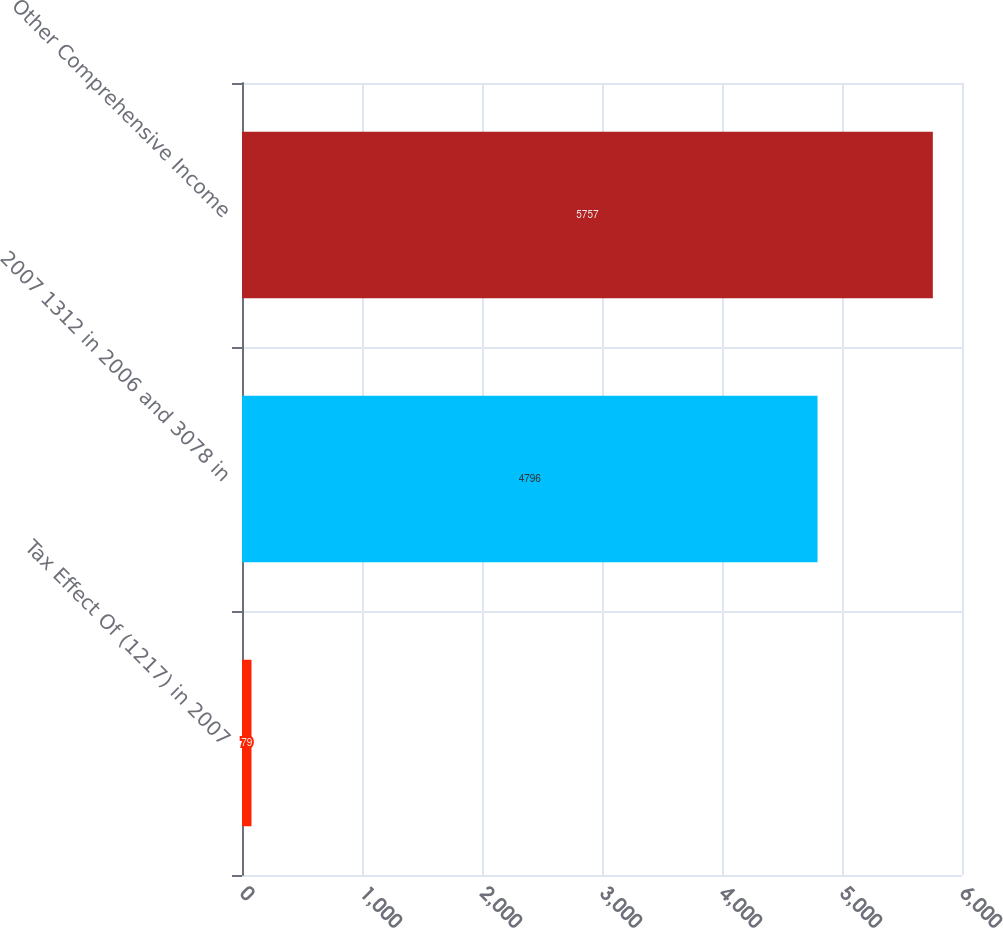Convert chart to OTSL. <chart><loc_0><loc_0><loc_500><loc_500><bar_chart><fcel>Tax Effect Of (1217) in 2007<fcel>2007 1312 in 2006 and 3078 in<fcel>Other Comprehensive Income<nl><fcel>79<fcel>4796<fcel>5757<nl></chart> 